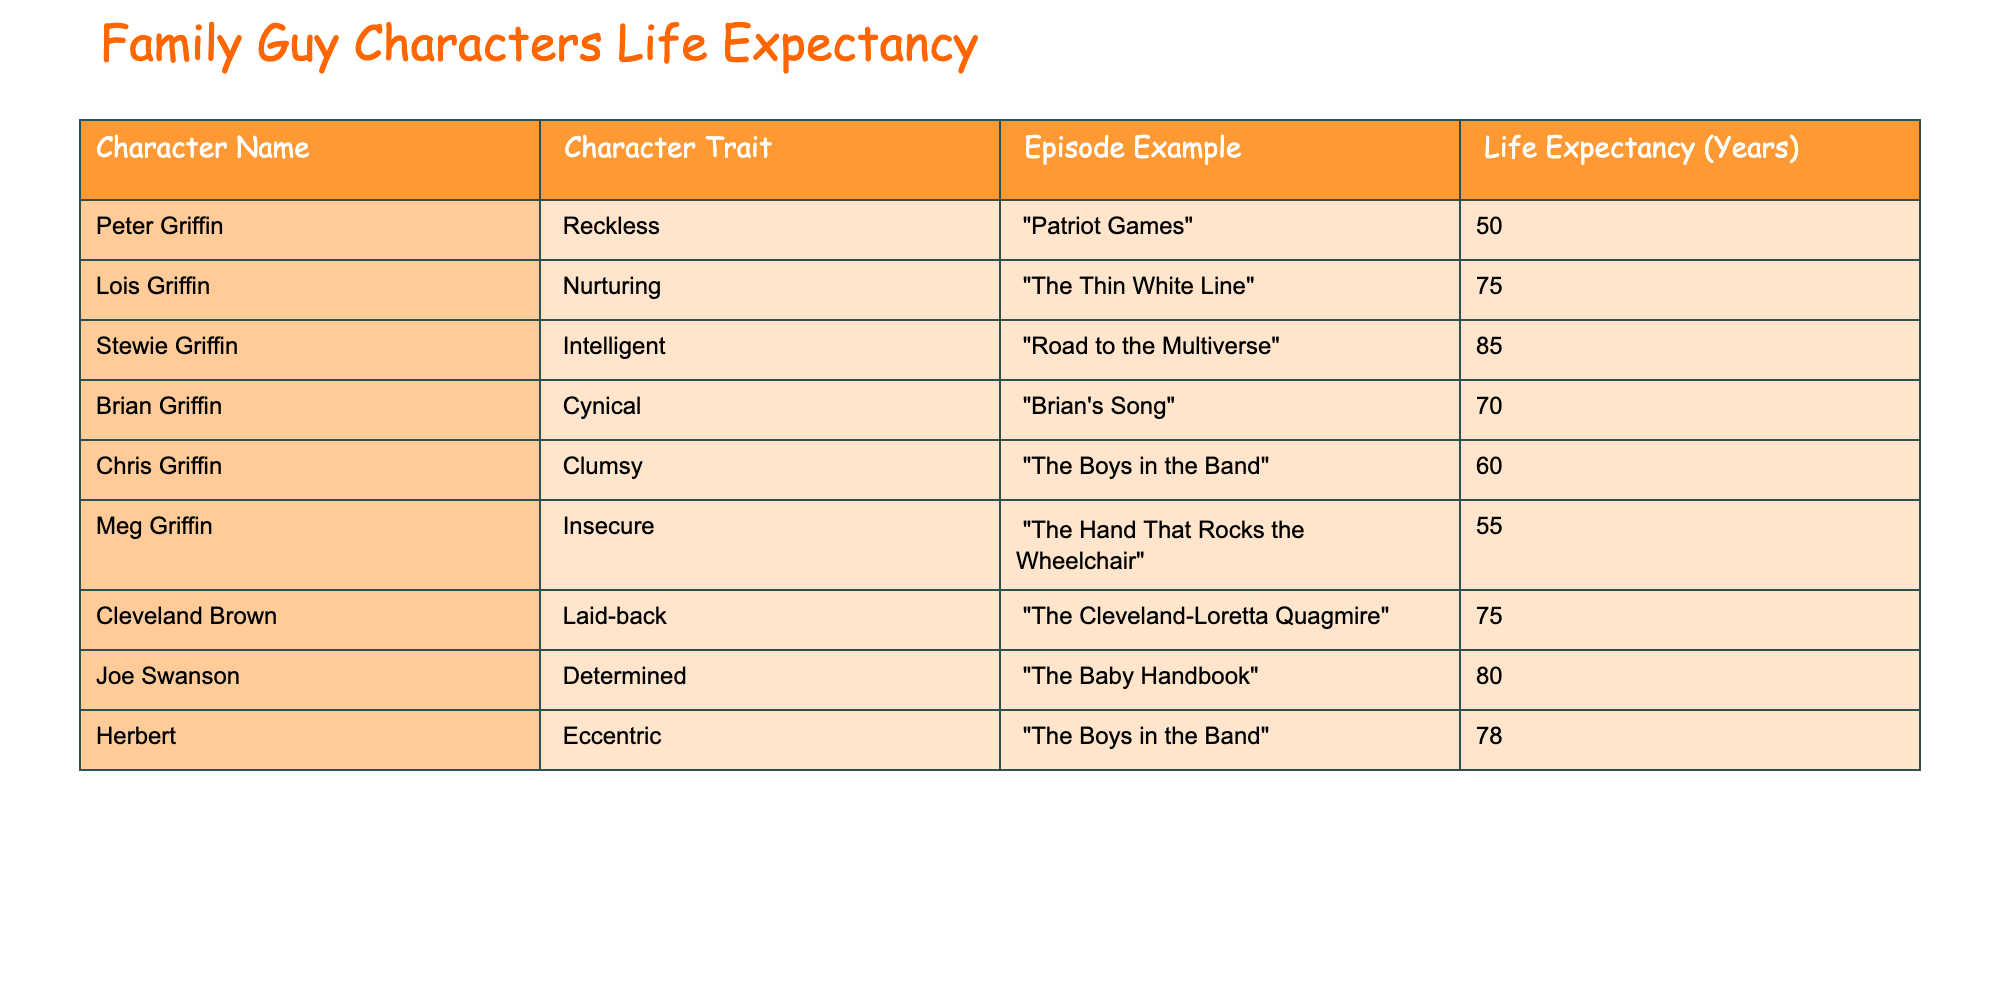What is the life expectancy of Stewie Griffin? The life expectancy for Stewie Griffin is directly listed in the table under "Life Expectancy." It is 85 years.
Answer: 85 Which character has the highest life expectancy? By examining the "Life Expectancy" column, Stewie Griffin has the highest life expectancy at 85 years, making him the character with the longest expected lifespan.
Answer: Stewie Griffin Is the life expectancy of Peter Griffin greater than that of Chris Griffin? Peter Griffin's life expectancy is 50 years, while Chris Griffin's is 60 years. Since 50 is less than 60, Peter does not have a greater life expectancy than Chris.
Answer: No What is the average life expectancy of all characters listed? To find the average life expectancy, sum all the values: (50 + 75 + 85 + 70 + 60 + 55 + 75 + 80 + 78) = 728. There are 9 characters, so the average is 728 / 9 = 80.89, approximately 81 years.
Answer: Approximately 81 How many characters have a life expectancy above 70 years? Reviewing the life expectancy values: Stewie Griffin (85), Joe Swanson (80), and Herbert (78) all have life expectancies above 70 years. Therefore, there are 3 characters who meet this criterion.
Answer: 3 Is Lois Griffin's life expectancy less than that of Cleveland Brown? Lois Griffin has a life expectancy of 75 years, and Cleveland Brown also has a life expectancy of 75 years. Since they are equal, Lois’s life expectancy is not less than Cleveland’s.
Answer: No What character traits are associated with the two characters that have the longest life expectancy? The characters with the longest life expectancy are Stewie Griffin (Intelligent, 85 years) and Joe Swanson (Determined, 80 years). Their traits are intelligence and determination, respectively.
Answer: Intelligent and Determined How does the life expectancy of the insecure character compare to the laid-back character? The insecure character, Meg Griffin, has a life expectancy of 55 years, while the laid-back character, Cleveland Brown, has 75 years. Comparing the two shows that Meg's life expectancy is lower than Cleveland's.
Answer: Lower Which trait is shared by characters with a life expectancy of 75 years? Both Lois Griffin and Cleveland Brown have a life expectancy of 75 years, and their traits are nurturing and laid-back, respectively. Therefore, no trait is shared between them, as they have different traits.
Answer: None shared 